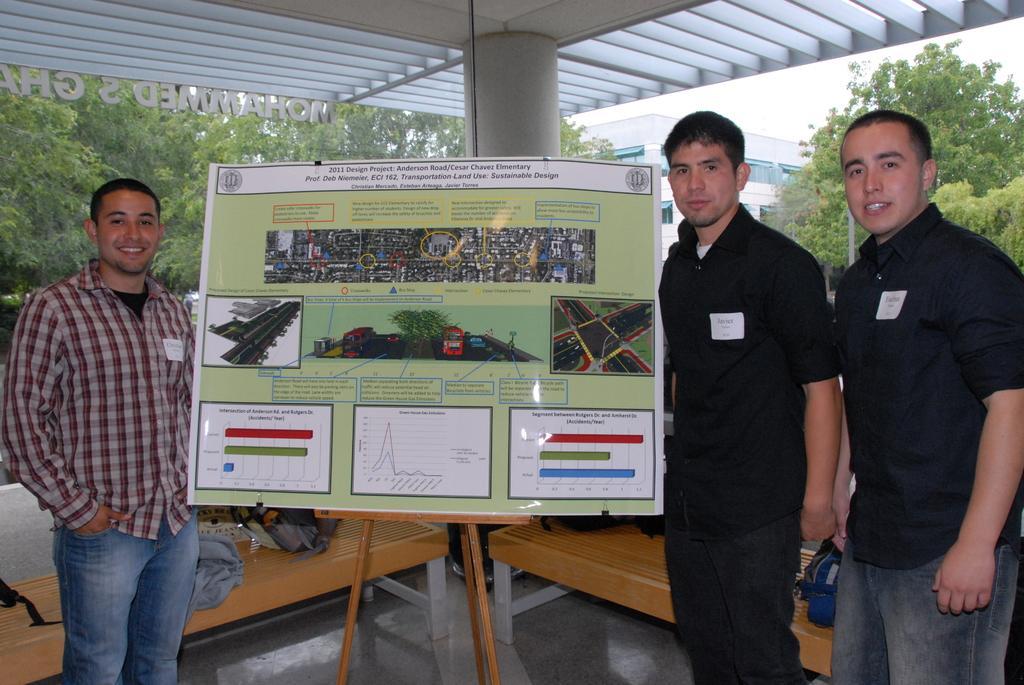Could you give a brief overview of what you see in this image? In this picture these three persons are standing. There is a banner with stand. On the background we can see trees and building and sky. There is a pillar. We can see bench. On the bench We can see bag,cloth. 